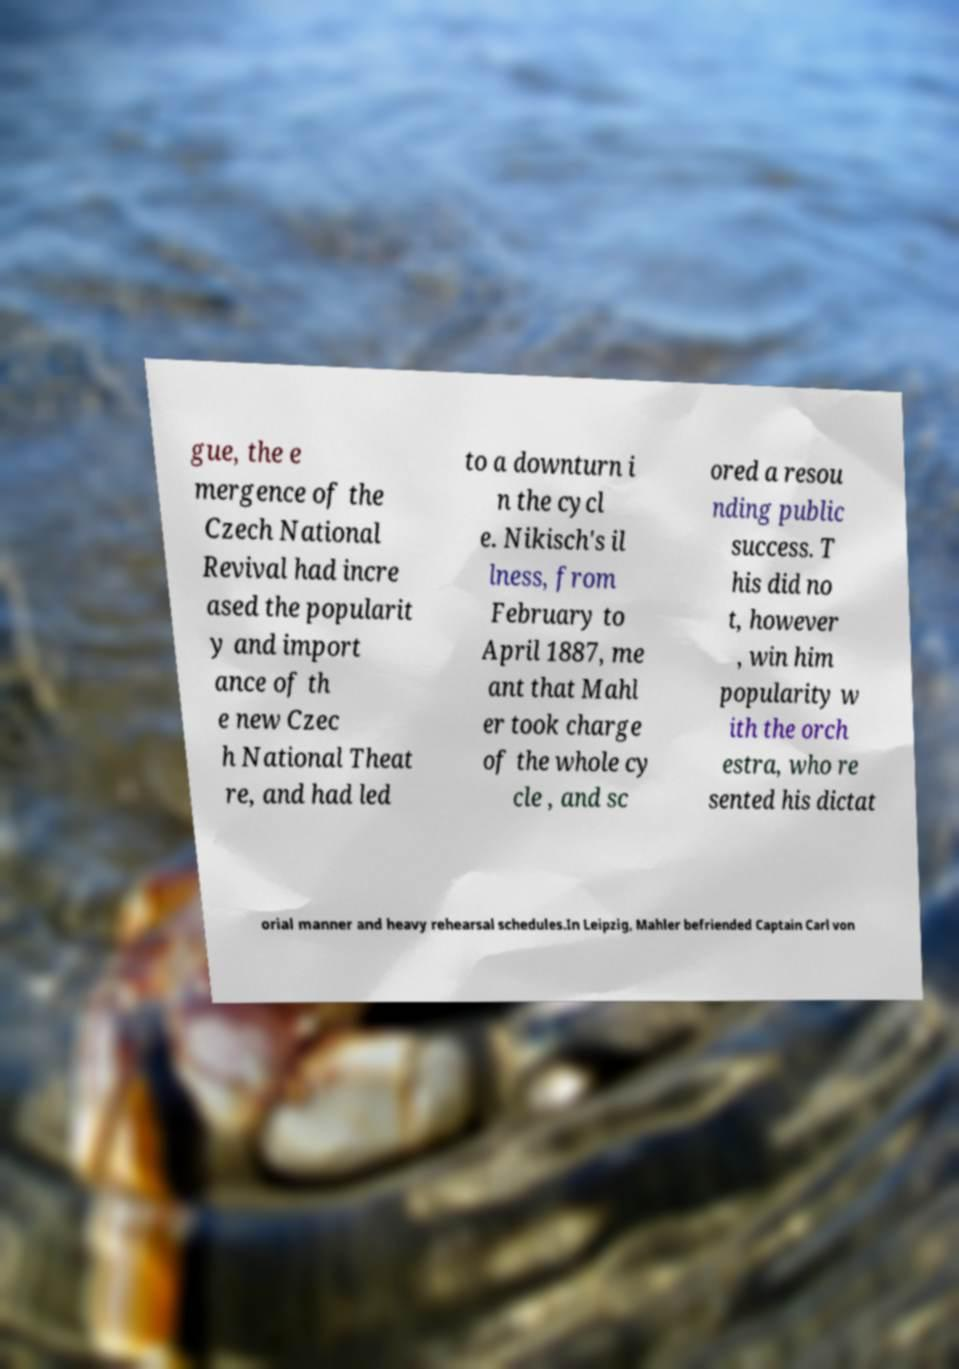Can you read and provide the text displayed in the image?This photo seems to have some interesting text. Can you extract and type it out for me? gue, the e mergence of the Czech National Revival had incre ased the popularit y and import ance of th e new Czec h National Theat re, and had led to a downturn i n the cycl e. Nikisch's il lness, from February to April 1887, me ant that Mahl er took charge of the whole cy cle , and sc ored a resou nding public success. T his did no t, however , win him popularity w ith the orch estra, who re sented his dictat orial manner and heavy rehearsal schedules.In Leipzig, Mahler befriended Captain Carl von 